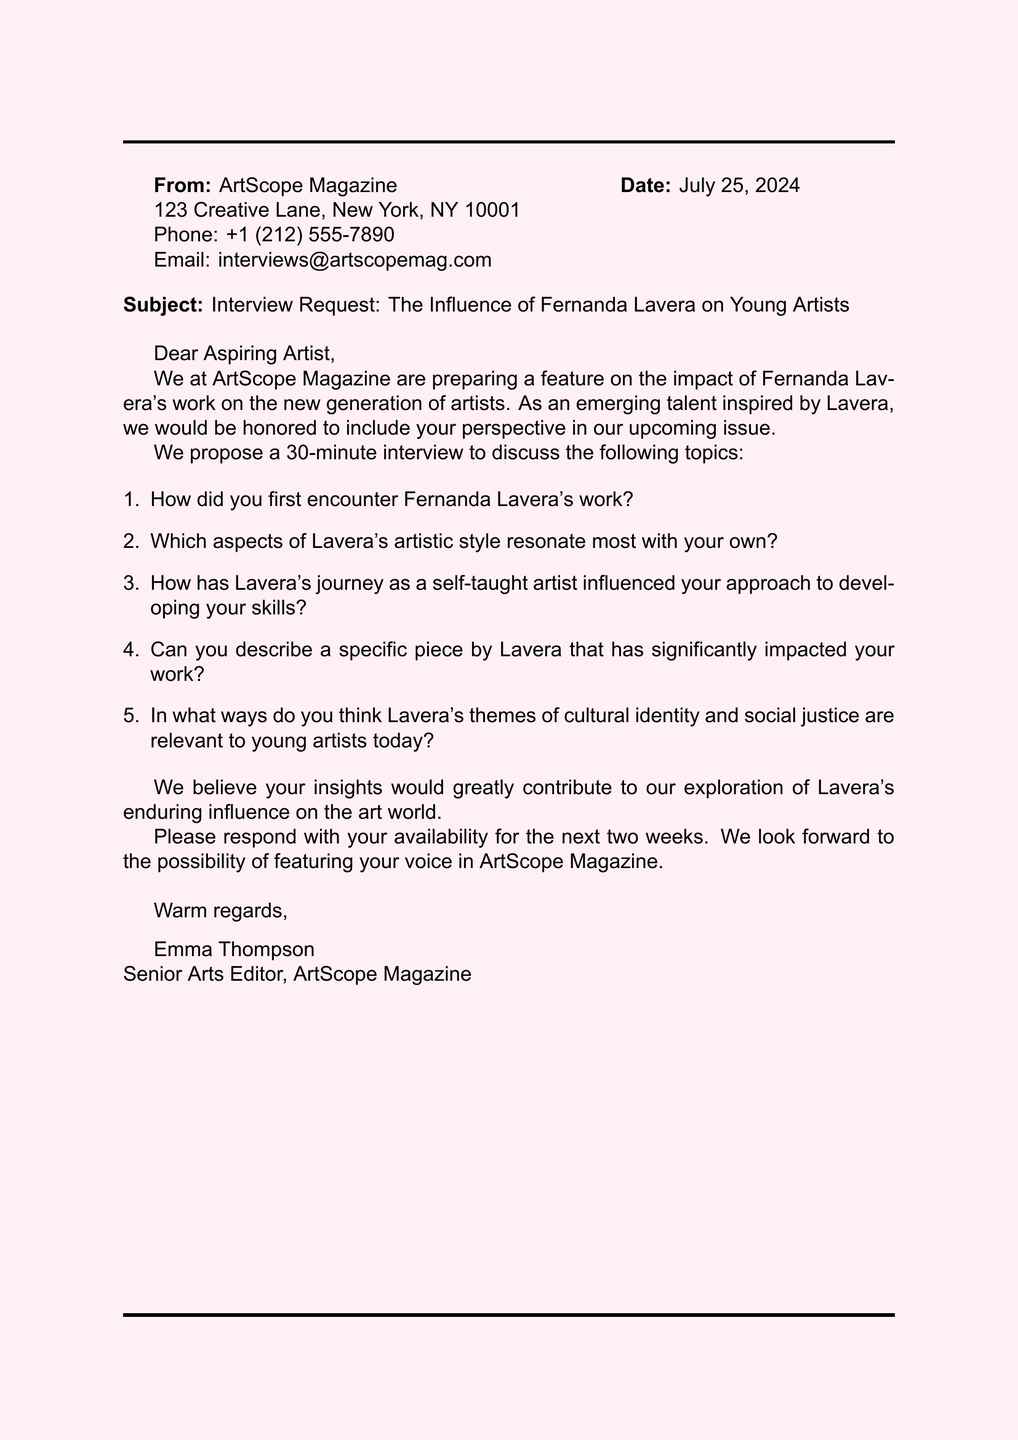What is the name of the magazine? The name of the magazine is mentioned in the document as ArtScope Magazine.
Answer: ArtScope Magazine Who is the Senior Arts Editor? The Senior Arts Editor's name is provided in the closing of the document.
Answer: Emma Thompson What is the subject of the fax? The subject line indicates the topic of the communication, which focuses on interviewing the artist.
Answer: Interview Request: The Influence of Fernanda Lavera on Young Artists How many questions are proposed for the interview? The number of interview questions listed in the document can be counted.
Answer: Five What is the date of the fax? The document includes the date in the header section, which will show the current date when rendered.
Answer: Today’s date Where is ArtScope Magazine located? The address of the magazine is specified in the contact information section.
Answer: 123 Creative Lane, New York, NY 10001 What type of interview duration is proposed? The document mentions the length of the interview in the invitation section.
Answer: 30 minutes What themes does Lavera's work address, according to the proposed questions? The proposed questions highlight certain themes in Lavera's work that the interview will address.
Answer: Cultural identity and social justice Which artistic approach of Fernanda Lavera is emphasized in the fax? The fax discusses how Lavera is described as a self-taught artist, influencing others.
Answer: Self-taught artist 